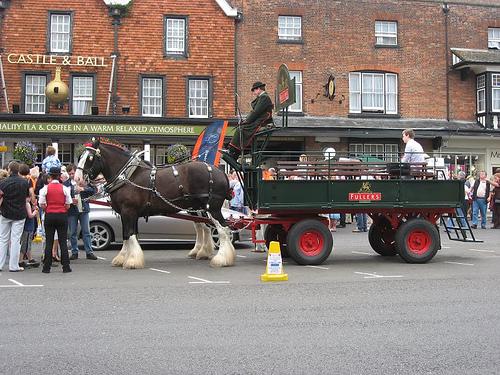How many red rims are on the wheels?
Quick response, please. 2. What are the men doing?
Write a very short answer. Standing. What keeps the horse from running away?
Concise answer only. Reins. How many window squares are in the picture?
Keep it brief. 100. 